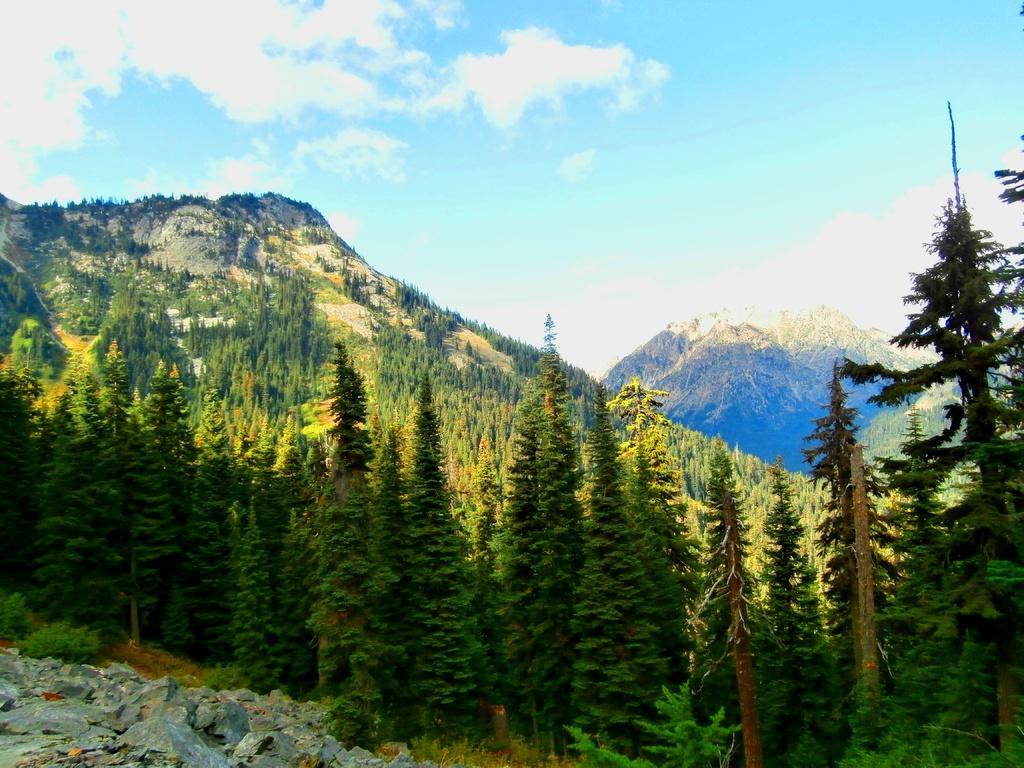Please provide a concise description of this image. In this image I see mountains and a number of trees and stones over here and the sky is pretty clear. 